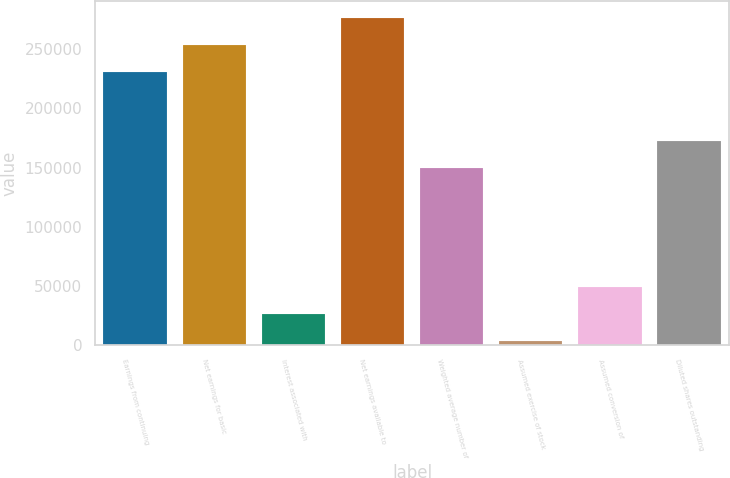<chart> <loc_0><loc_0><loc_500><loc_500><bar_chart><fcel>Earnings from continuing<fcel>Net earnings for basic<fcel>Interest associated with<fcel>Net earnings available to<fcel>Weighted average number of<fcel>Assumed exercise of stock<fcel>Assumed conversion of<fcel>Diluted shares outstanding<nl><fcel>230213<fcel>253241<fcel>26546<fcel>276269<fcel>149405<fcel>3518<fcel>49574<fcel>172433<nl></chart> 